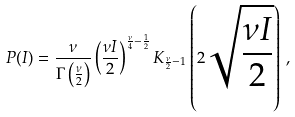<formula> <loc_0><loc_0><loc_500><loc_500>P ( I ) = \frac { \nu } { \Gamma \left ( \frac { \nu } { 2 } \right ) } \left ( \frac { \nu I } { 2 } \right ) ^ { \frac { \nu } { 4 } - \frac { 1 } { 2 } } K _ { \frac { \nu } { 2 } - 1 } \left ( 2 \sqrt { \frac { \nu I } { 2 } } \right ) \, ,</formula> 